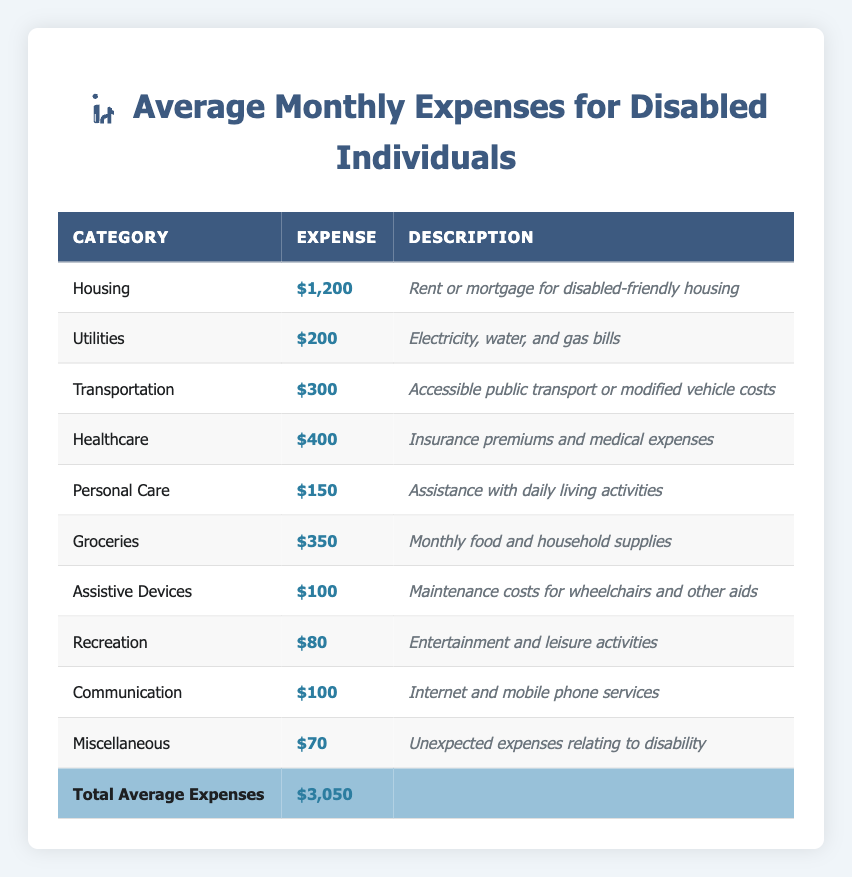What is the total average monthly expense for disabled individuals? The table shows a total average expense of $3,050 in the last row under "Total Average Expenses."
Answer: $3,050 Which category has the highest monthly expense? The "Housing" category has the highest expense listed at $1,200.
Answer: Housing What is the monthly expense for personal care? The "Personal Care" category indicates an expense of $150.
Answer: $150 Is the monthly expense for communication higher than that for recreation? The expense for communication is $100, while recreation is $80, so communication is higher.
Answer: Yes What would be the total of healthcare, transportation, and personal care expenses? Adding these expenses: $400 (healthcare) + $300 (transportation) + $150 (personal care) = $850.
Answer: $850 How much more do disabled individuals spend on housing compared to transportation? Housing costs $1,200 while transportation costs $300. The difference is $1,200 - $300 = $900.
Answer: $900 What percentage of the total expenses is spent on groceries? Groceries cost $350, and the total expenses are $3,050. ($350 / $3,050) * 100 = approximately 11.48%.
Answer: 11.48% If we combine the expenses for assistive devices and recreation, how much will it be? Assistive devices cost $100 and recreation costs $80, so the total is $100 + $80 = $180.
Answer: $180 Is the total spent on utilities and communication more than the total spent on personal care and groceries combined? Utilities ($200) + Communication ($100) = $300. Personal Care ($150) + Groceries ($350) = $500. $300 is not more than $500.
Answer: No What is the difference between the expense for healthcare and the total spent on assistive devices and recreation? Healthcare costs $400. Assistive devices ($100) + Recreation ($80) = $180. The difference is $400 - $180 = $220.
Answer: $220 